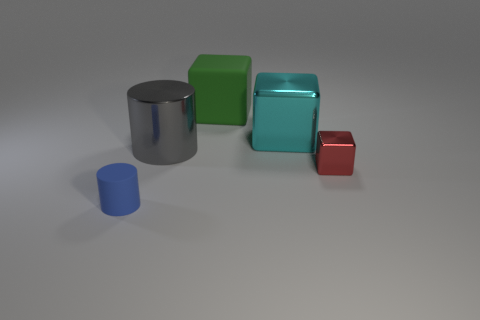How many metal objects are purple cylinders or large gray cylinders?
Your answer should be very brief. 1. How many blue objects are there?
Offer a very short reply. 1. Does the small thing on the left side of the gray metallic cylinder have the same material as the cylinder behind the small block?
Ensure brevity in your answer.  No. The other large matte object that is the same shape as the cyan object is what color?
Your answer should be compact. Green. There is a object to the right of the large thing that is to the right of the green matte object; what is its material?
Your response must be concise. Metal. Do the object in front of the red cube and the big metal thing to the left of the large cyan metallic cube have the same shape?
Provide a succinct answer. Yes. How big is the thing that is both on the right side of the blue cylinder and left of the rubber cube?
Offer a very short reply. Large. What number of other things are there of the same color as the big rubber cube?
Keep it short and to the point. 0. Is the material of the small object that is right of the large matte object the same as the tiny blue object?
Keep it short and to the point. No. Is the number of big matte cubes that are in front of the green matte block less than the number of big metal blocks that are on the right side of the tiny matte cylinder?
Keep it short and to the point. Yes. 